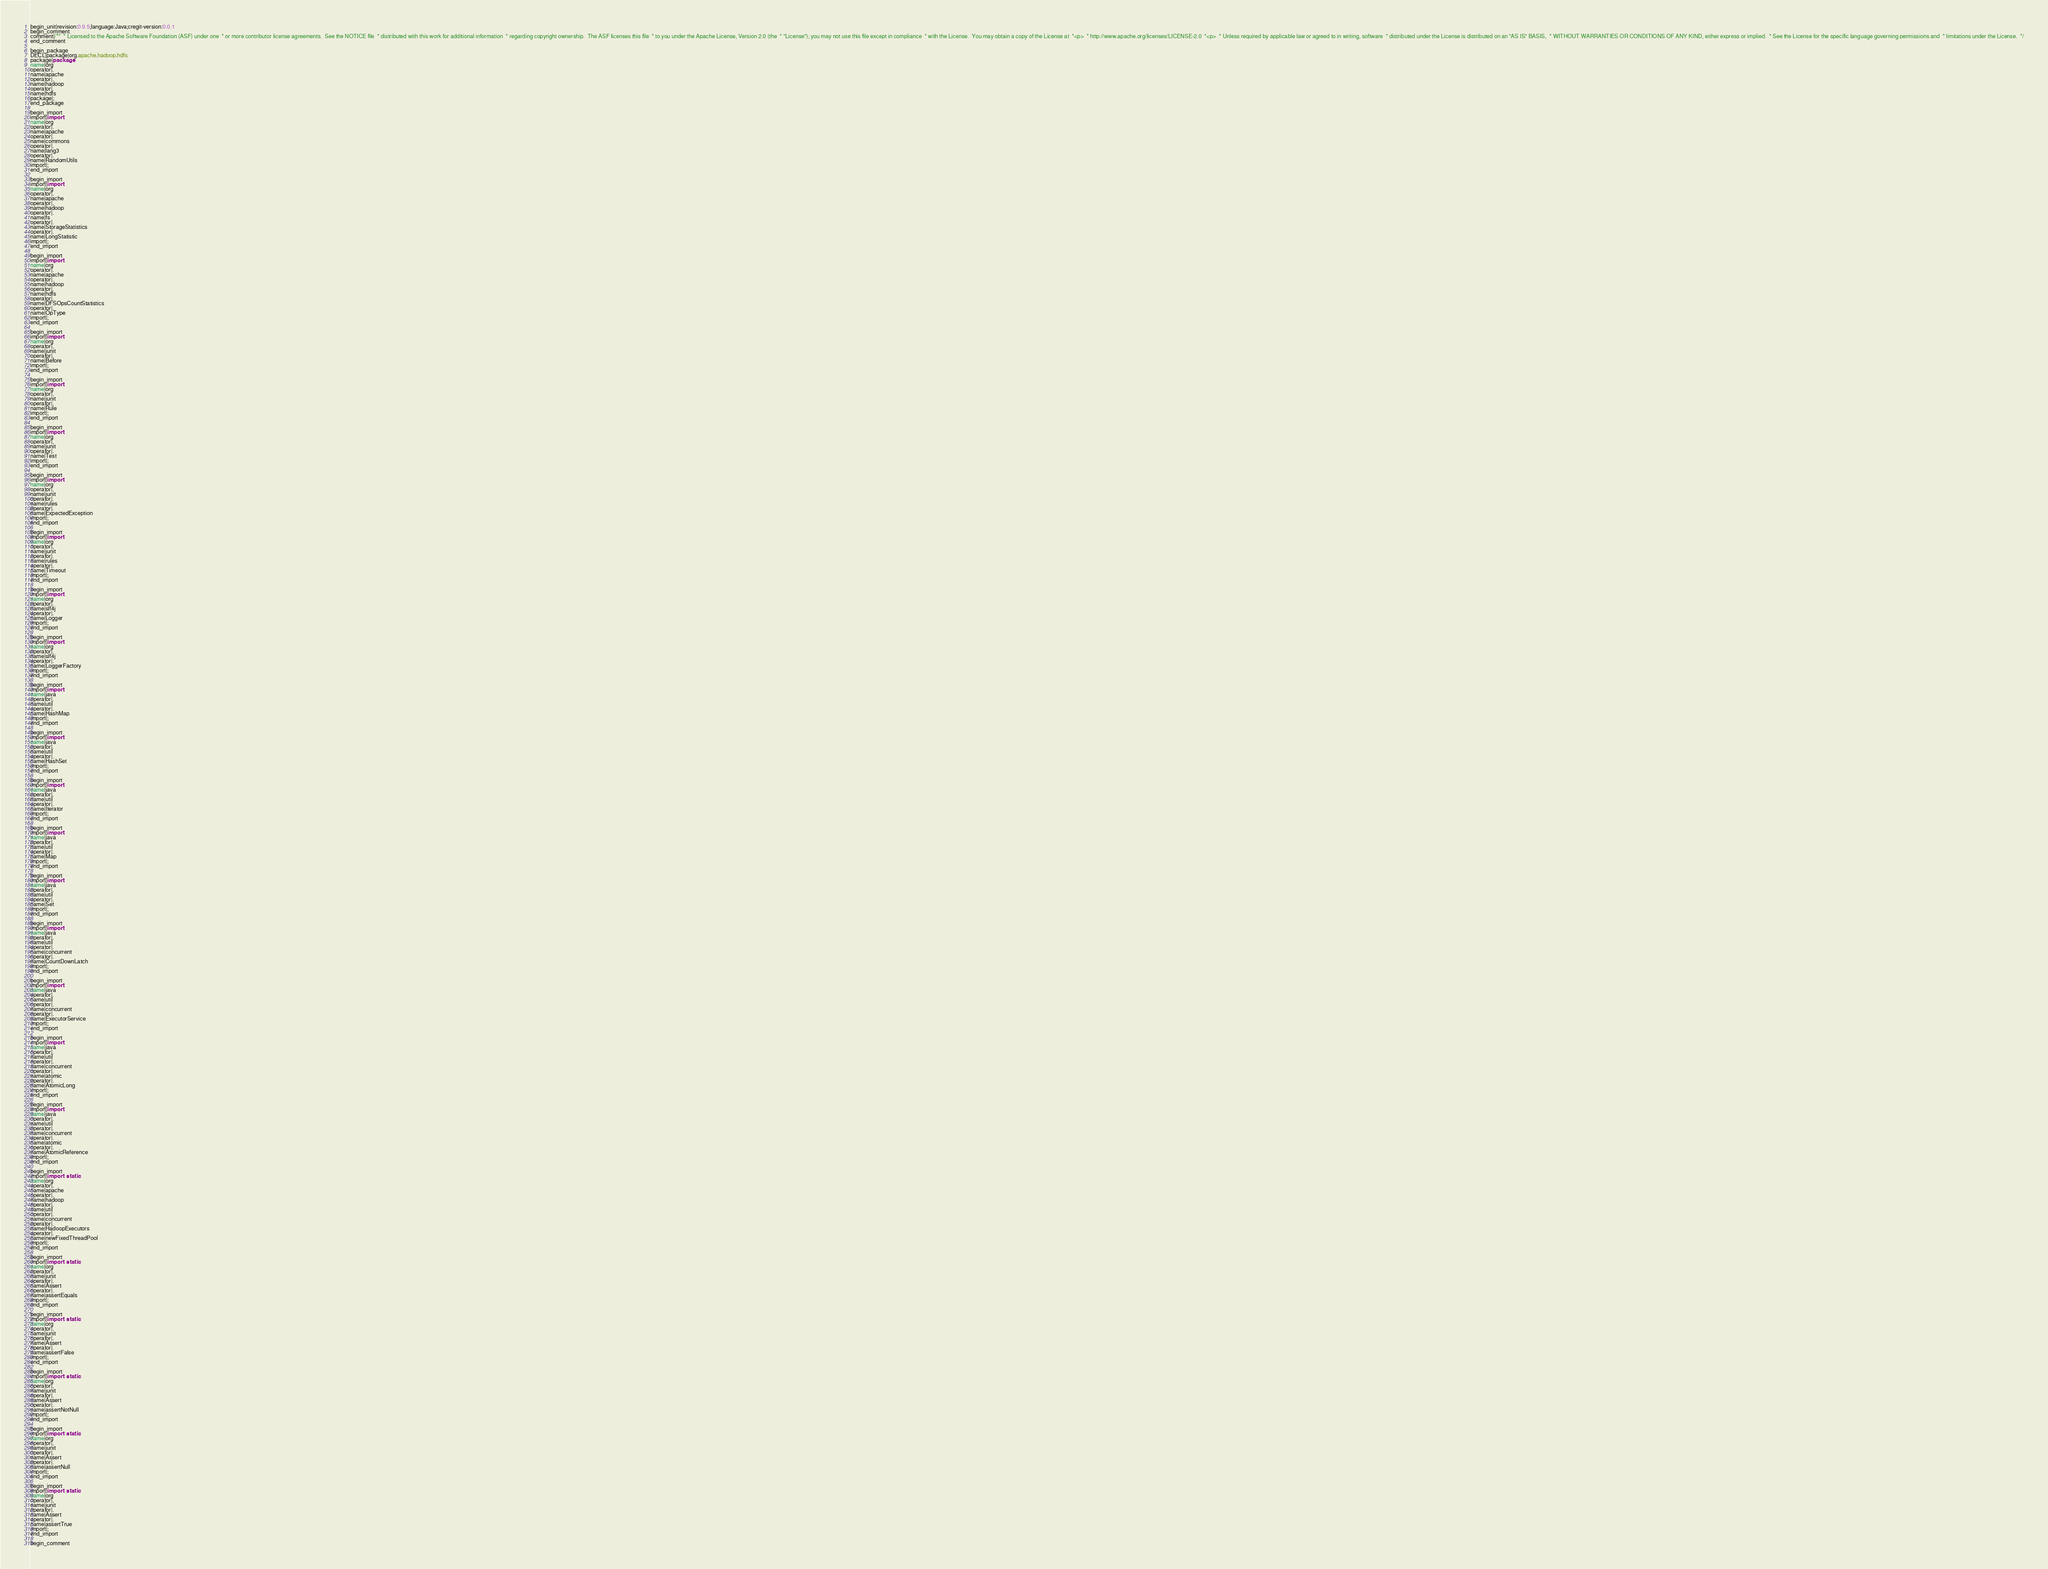<code> <loc_0><loc_0><loc_500><loc_500><_Java_>begin_unit|revision:0.9.5;language:Java;cregit-version:0.0.1
begin_comment
comment|/**  * Licensed to the Apache Software Foundation (ASF) under one  * or more contributor license agreements.  See the NOTICE file  * distributed with this work for additional information  * regarding copyright ownership.  The ASF licenses this file  * to you under the Apache License, Version 2.0 (the  * "License"); you may not use this file except in compliance  * with the License.  You may obtain a copy of the License at  *<p>  * http://www.apache.org/licenses/LICENSE-2.0  *<p>  * Unless required by applicable law or agreed to in writing, software  * distributed under the License is distributed on an "AS IS" BASIS,  * WITHOUT WARRANTIES OR CONDITIONS OF ANY KIND, either express or implied.  * See the License for the specific language governing permissions and  * limitations under the License.  */
end_comment

begin_package
DECL|package|org.apache.hadoop.hdfs
package|package
name|org
operator|.
name|apache
operator|.
name|hadoop
operator|.
name|hdfs
package|;
end_package

begin_import
import|import
name|org
operator|.
name|apache
operator|.
name|commons
operator|.
name|lang3
operator|.
name|RandomUtils
import|;
end_import

begin_import
import|import
name|org
operator|.
name|apache
operator|.
name|hadoop
operator|.
name|fs
operator|.
name|StorageStatistics
operator|.
name|LongStatistic
import|;
end_import

begin_import
import|import
name|org
operator|.
name|apache
operator|.
name|hadoop
operator|.
name|hdfs
operator|.
name|DFSOpsCountStatistics
operator|.
name|OpType
import|;
end_import

begin_import
import|import
name|org
operator|.
name|junit
operator|.
name|Before
import|;
end_import

begin_import
import|import
name|org
operator|.
name|junit
operator|.
name|Rule
import|;
end_import

begin_import
import|import
name|org
operator|.
name|junit
operator|.
name|Test
import|;
end_import

begin_import
import|import
name|org
operator|.
name|junit
operator|.
name|rules
operator|.
name|ExpectedException
import|;
end_import

begin_import
import|import
name|org
operator|.
name|junit
operator|.
name|rules
operator|.
name|Timeout
import|;
end_import

begin_import
import|import
name|org
operator|.
name|slf4j
operator|.
name|Logger
import|;
end_import

begin_import
import|import
name|org
operator|.
name|slf4j
operator|.
name|LoggerFactory
import|;
end_import

begin_import
import|import
name|java
operator|.
name|util
operator|.
name|HashMap
import|;
end_import

begin_import
import|import
name|java
operator|.
name|util
operator|.
name|HashSet
import|;
end_import

begin_import
import|import
name|java
operator|.
name|util
operator|.
name|Iterator
import|;
end_import

begin_import
import|import
name|java
operator|.
name|util
operator|.
name|Map
import|;
end_import

begin_import
import|import
name|java
operator|.
name|util
operator|.
name|Set
import|;
end_import

begin_import
import|import
name|java
operator|.
name|util
operator|.
name|concurrent
operator|.
name|CountDownLatch
import|;
end_import

begin_import
import|import
name|java
operator|.
name|util
operator|.
name|concurrent
operator|.
name|ExecutorService
import|;
end_import

begin_import
import|import
name|java
operator|.
name|util
operator|.
name|concurrent
operator|.
name|atomic
operator|.
name|AtomicLong
import|;
end_import

begin_import
import|import
name|java
operator|.
name|util
operator|.
name|concurrent
operator|.
name|atomic
operator|.
name|AtomicReference
import|;
end_import

begin_import
import|import static
name|org
operator|.
name|apache
operator|.
name|hadoop
operator|.
name|util
operator|.
name|concurrent
operator|.
name|HadoopExecutors
operator|.
name|newFixedThreadPool
import|;
end_import

begin_import
import|import static
name|org
operator|.
name|junit
operator|.
name|Assert
operator|.
name|assertEquals
import|;
end_import

begin_import
import|import static
name|org
operator|.
name|junit
operator|.
name|Assert
operator|.
name|assertFalse
import|;
end_import

begin_import
import|import static
name|org
operator|.
name|junit
operator|.
name|Assert
operator|.
name|assertNotNull
import|;
end_import

begin_import
import|import static
name|org
operator|.
name|junit
operator|.
name|Assert
operator|.
name|assertNull
import|;
end_import

begin_import
import|import static
name|org
operator|.
name|junit
operator|.
name|Assert
operator|.
name|assertTrue
import|;
end_import

begin_comment</code> 